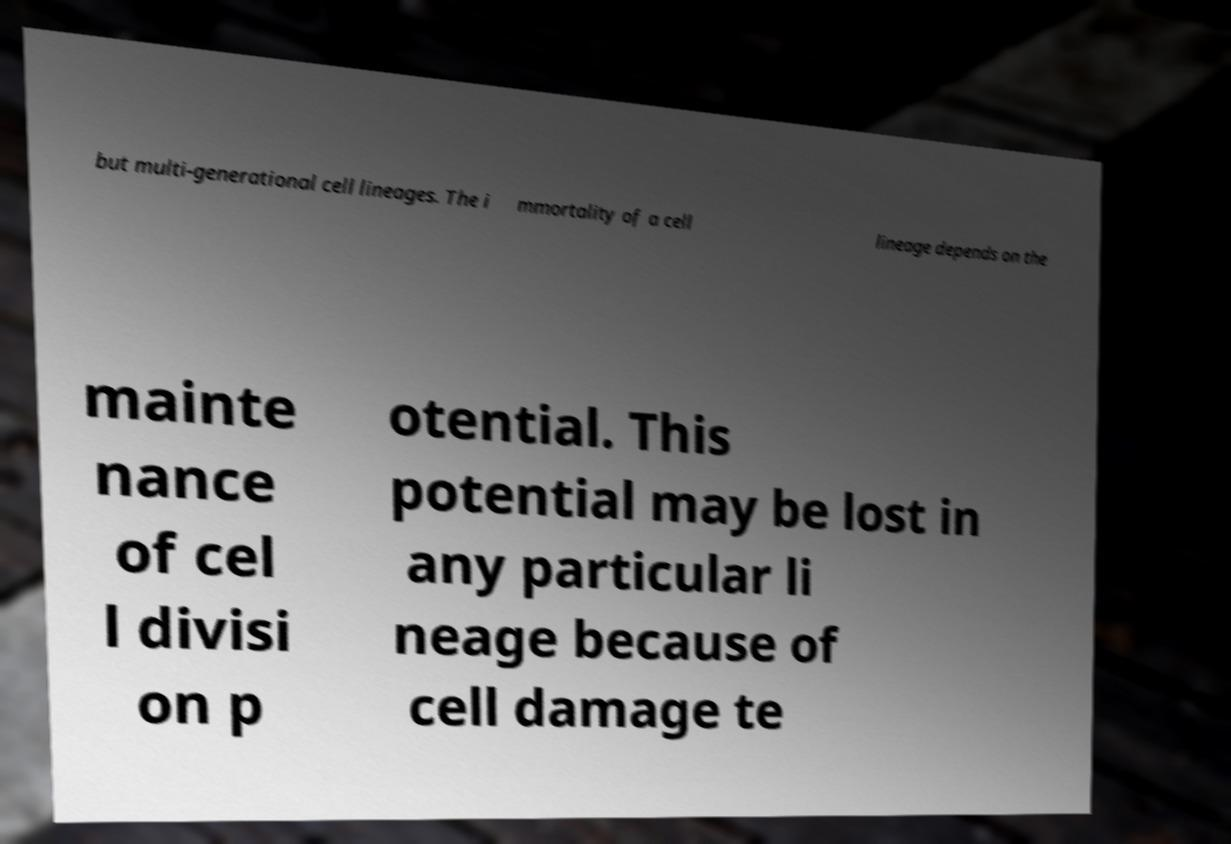Can you read and provide the text displayed in the image?This photo seems to have some interesting text. Can you extract and type it out for me? but multi-generational cell lineages. The i mmortality of a cell lineage depends on the mainte nance of cel l divisi on p otential. This potential may be lost in any particular li neage because of cell damage te 